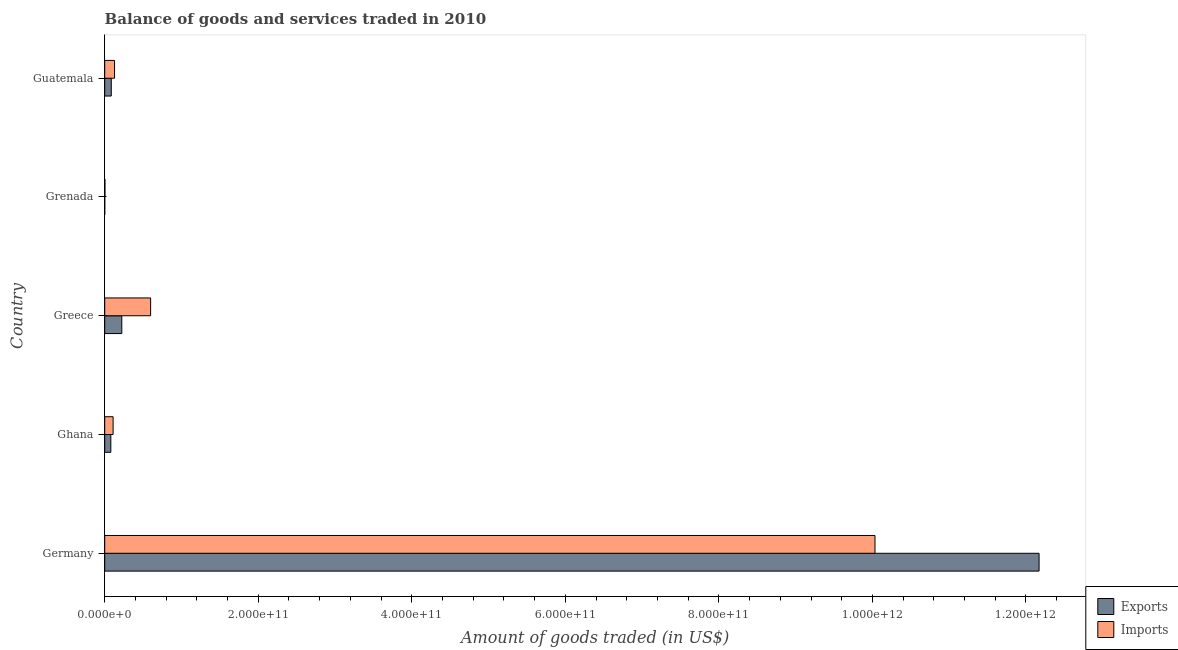How many groups of bars are there?
Your response must be concise. 5. What is the label of the 2nd group of bars from the top?
Give a very brief answer. Grenada. What is the amount of goods exported in Grenada?
Your answer should be very brief. 3.11e+07. Across all countries, what is the maximum amount of goods exported?
Offer a terse response. 1.22e+12. Across all countries, what is the minimum amount of goods imported?
Give a very brief answer. 2.86e+08. In which country was the amount of goods exported minimum?
Your answer should be very brief. Grenada. What is the total amount of goods imported in the graph?
Give a very brief answer. 1.09e+12. What is the difference between the amount of goods exported in Germany and that in Grenada?
Keep it short and to the point. 1.22e+12. What is the difference between the amount of goods exported in Grenada and the amount of goods imported in Ghana?
Provide a succinct answer. -1.09e+1. What is the average amount of goods imported per country?
Offer a terse response. 2.17e+11. What is the difference between the amount of goods imported and amount of goods exported in Guatemala?
Your response must be concise. 4.27e+09. What is the ratio of the amount of goods exported in Germany to that in Guatemala?
Your answer should be compact. 142.59. What is the difference between the highest and the second highest amount of goods imported?
Offer a terse response. 9.44e+11. What is the difference between the highest and the lowest amount of goods exported?
Keep it short and to the point. 1.22e+12. In how many countries, is the amount of goods imported greater than the average amount of goods imported taken over all countries?
Provide a short and direct response. 1. What does the 2nd bar from the top in Guatemala represents?
Provide a short and direct response. Exports. What does the 2nd bar from the bottom in Ghana represents?
Your answer should be compact. Imports. How many bars are there?
Offer a terse response. 10. Are all the bars in the graph horizontal?
Make the answer very short. Yes. How many countries are there in the graph?
Give a very brief answer. 5. What is the difference between two consecutive major ticks on the X-axis?
Offer a very short reply. 2.00e+11. Does the graph contain any zero values?
Your answer should be compact. No. Where does the legend appear in the graph?
Keep it short and to the point. Bottom right. How many legend labels are there?
Provide a succinct answer. 2. How are the legend labels stacked?
Make the answer very short. Vertical. What is the title of the graph?
Give a very brief answer. Balance of goods and services traded in 2010. What is the label or title of the X-axis?
Your response must be concise. Amount of goods traded (in US$). What is the Amount of goods traded (in US$) in Exports in Germany?
Give a very brief answer. 1.22e+12. What is the Amount of goods traded (in US$) in Imports in Germany?
Make the answer very short. 1.00e+12. What is the Amount of goods traded (in US$) of Exports in Ghana?
Provide a succinct answer. 7.96e+09. What is the Amount of goods traded (in US$) in Imports in Ghana?
Provide a short and direct response. 1.09e+1. What is the Amount of goods traded (in US$) of Exports in Greece?
Give a very brief answer. 2.22e+1. What is the Amount of goods traded (in US$) of Imports in Greece?
Offer a terse response. 5.98e+1. What is the Amount of goods traded (in US$) in Exports in Grenada?
Offer a terse response. 3.11e+07. What is the Amount of goods traded (in US$) in Imports in Grenada?
Make the answer very short. 2.86e+08. What is the Amount of goods traded (in US$) in Exports in Guatemala?
Offer a terse response. 8.54e+09. What is the Amount of goods traded (in US$) of Imports in Guatemala?
Your answer should be compact. 1.28e+1. Across all countries, what is the maximum Amount of goods traded (in US$) in Exports?
Your response must be concise. 1.22e+12. Across all countries, what is the maximum Amount of goods traded (in US$) of Imports?
Offer a terse response. 1.00e+12. Across all countries, what is the minimum Amount of goods traded (in US$) of Exports?
Ensure brevity in your answer.  3.11e+07. Across all countries, what is the minimum Amount of goods traded (in US$) of Imports?
Make the answer very short. 2.86e+08. What is the total Amount of goods traded (in US$) of Exports in the graph?
Give a very brief answer. 1.26e+12. What is the total Amount of goods traded (in US$) of Imports in the graph?
Offer a very short reply. 1.09e+12. What is the difference between the Amount of goods traded (in US$) of Exports in Germany and that in Ghana?
Offer a terse response. 1.21e+12. What is the difference between the Amount of goods traded (in US$) in Imports in Germany and that in Ghana?
Your answer should be compact. 9.92e+11. What is the difference between the Amount of goods traded (in US$) of Exports in Germany and that in Greece?
Ensure brevity in your answer.  1.19e+12. What is the difference between the Amount of goods traded (in US$) in Imports in Germany and that in Greece?
Provide a succinct answer. 9.44e+11. What is the difference between the Amount of goods traded (in US$) in Exports in Germany and that in Grenada?
Keep it short and to the point. 1.22e+12. What is the difference between the Amount of goods traded (in US$) in Imports in Germany and that in Grenada?
Your response must be concise. 1.00e+12. What is the difference between the Amount of goods traded (in US$) in Exports in Germany and that in Guatemala?
Offer a terse response. 1.21e+12. What is the difference between the Amount of goods traded (in US$) of Imports in Germany and that in Guatemala?
Keep it short and to the point. 9.91e+11. What is the difference between the Amount of goods traded (in US$) of Exports in Ghana and that in Greece?
Offer a very short reply. -1.43e+1. What is the difference between the Amount of goods traded (in US$) in Imports in Ghana and that in Greece?
Your answer should be very brief. -4.89e+1. What is the difference between the Amount of goods traded (in US$) in Exports in Ghana and that in Grenada?
Provide a succinct answer. 7.93e+09. What is the difference between the Amount of goods traded (in US$) in Imports in Ghana and that in Grenada?
Provide a succinct answer. 1.06e+1. What is the difference between the Amount of goods traded (in US$) in Exports in Ghana and that in Guatemala?
Your answer should be compact. -5.75e+08. What is the difference between the Amount of goods traded (in US$) in Imports in Ghana and that in Guatemala?
Your answer should be very brief. -1.88e+09. What is the difference between the Amount of goods traded (in US$) of Exports in Greece and that in Grenada?
Provide a succinct answer. 2.22e+1. What is the difference between the Amount of goods traded (in US$) of Imports in Greece and that in Grenada?
Your response must be concise. 5.95e+1. What is the difference between the Amount of goods traded (in US$) in Exports in Greece and that in Guatemala?
Give a very brief answer. 1.37e+1. What is the difference between the Amount of goods traded (in US$) in Imports in Greece and that in Guatemala?
Your answer should be compact. 4.70e+1. What is the difference between the Amount of goods traded (in US$) of Exports in Grenada and that in Guatemala?
Give a very brief answer. -8.50e+09. What is the difference between the Amount of goods traded (in US$) of Imports in Grenada and that in Guatemala?
Provide a short and direct response. -1.25e+1. What is the difference between the Amount of goods traded (in US$) in Exports in Germany and the Amount of goods traded (in US$) in Imports in Ghana?
Keep it short and to the point. 1.21e+12. What is the difference between the Amount of goods traded (in US$) in Exports in Germany and the Amount of goods traded (in US$) in Imports in Greece?
Your answer should be compact. 1.16e+12. What is the difference between the Amount of goods traded (in US$) of Exports in Germany and the Amount of goods traded (in US$) of Imports in Grenada?
Your answer should be very brief. 1.22e+12. What is the difference between the Amount of goods traded (in US$) of Exports in Germany and the Amount of goods traded (in US$) of Imports in Guatemala?
Give a very brief answer. 1.20e+12. What is the difference between the Amount of goods traded (in US$) of Exports in Ghana and the Amount of goods traded (in US$) of Imports in Greece?
Your response must be concise. -5.18e+1. What is the difference between the Amount of goods traded (in US$) of Exports in Ghana and the Amount of goods traded (in US$) of Imports in Grenada?
Offer a very short reply. 7.67e+09. What is the difference between the Amount of goods traded (in US$) of Exports in Ghana and the Amount of goods traded (in US$) of Imports in Guatemala?
Offer a terse response. -4.85e+09. What is the difference between the Amount of goods traded (in US$) of Exports in Greece and the Amount of goods traded (in US$) of Imports in Grenada?
Your answer should be very brief. 2.20e+1. What is the difference between the Amount of goods traded (in US$) in Exports in Greece and the Amount of goods traded (in US$) in Imports in Guatemala?
Make the answer very short. 9.44e+09. What is the difference between the Amount of goods traded (in US$) in Exports in Grenada and the Amount of goods traded (in US$) in Imports in Guatemala?
Provide a succinct answer. -1.28e+1. What is the average Amount of goods traded (in US$) in Exports per country?
Provide a succinct answer. 2.51e+11. What is the average Amount of goods traded (in US$) in Imports per country?
Offer a very short reply. 2.17e+11. What is the difference between the Amount of goods traded (in US$) of Exports and Amount of goods traded (in US$) of Imports in Germany?
Offer a terse response. 2.14e+11. What is the difference between the Amount of goods traded (in US$) of Exports and Amount of goods traded (in US$) of Imports in Ghana?
Your response must be concise. -2.96e+09. What is the difference between the Amount of goods traded (in US$) of Exports and Amount of goods traded (in US$) of Imports in Greece?
Offer a very short reply. -3.76e+1. What is the difference between the Amount of goods traded (in US$) of Exports and Amount of goods traded (in US$) of Imports in Grenada?
Give a very brief answer. -2.54e+08. What is the difference between the Amount of goods traded (in US$) in Exports and Amount of goods traded (in US$) in Imports in Guatemala?
Your answer should be very brief. -4.27e+09. What is the ratio of the Amount of goods traded (in US$) in Exports in Germany to that in Ghana?
Give a very brief answer. 152.9. What is the ratio of the Amount of goods traded (in US$) of Imports in Germany to that in Ghana?
Make the answer very short. 91.86. What is the ratio of the Amount of goods traded (in US$) in Exports in Germany to that in Greece?
Offer a terse response. 54.7. What is the ratio of the Amount of goods traded (in US$) of Imports in Germany to that in Greece?
Provide a short and direct response. 16.78. What is the ratio of the Amount of goods traded (in US$) of Exports in Germany to that in Grenada?
Offer a terse response. 3.91e+04. What is the ratio of the Amount of goods traded (in US$) in Imports in Germany to that in Grenada?
Offer a terse response. 3513.43. What is the ratio of the Amount of goods traded (in US$) in Exports in Germany to that in Guatemala?
Your answer should be compact. 142.59. What is the ratio of the Amount of goods traded (in US$) in Imports in Germany to that in Guatemala?
Your answer should be compact. 78.35. What is the ratio of the Amount of goods traded (in US$) of Exports in Ghana to that in Greece?
Provide a succinct answer. 0.36. What is the ratio of the Amount of goods traded (in US$) in Imports in Ghana to that in Greece?
Your answer should be compact. 0.18. What is the ratio of the Amount of goods traded (in US$) of Exports in Ghana to that in Grenada?
Give a very brief answer. 255.73. What is the ratio of the Amount of goods traded (in US$) in Imports in Ghana to that in Grenada?
Offer a very short reply. 38.25. What is the ratio of the Amount of goods traded (in US$) in Exports in Ghana to that in Guatemala?
Offer a terse response. 0.93. What is the ratio of the Amount of goods traded (in US$) of Imports in Ghana to that in Guatemala?
Provide a succinct answer. 0.85. What is the ratio of the Amount of goods traded (in US$) of Exports in Greece to that in Grenada?
Your answer should be compact. 714.8. What is the ratio of the Amount of goods traded (in US$) of Imports in Greece to that in Grenada?
Your answer should be very brief. 209.41. What is the ratio of the Amount of goods traded (in US$) of Exports in Greece to that in Guatemala?
Your response must be concise. 2.61. What is the ratio of the Amount of goods traded (in US$) of Imports in Greece to that in Guatemala?
Offer a very short reply. 4.67. What is the ratio of the Amount of goods traded (in US$) in Exports in Grenada to that in Guatemala?
Your answer should be compact. 0. What is the ratio of the Amount of goods traded (in US$) in Imports in Grenada to that in Guatemala?
Keep it short and to the point. 0.02. What is the difference between the highest and the second highest Amount of goods traded (in US$) in Exports?
Ensure brevity in your answer.  1.19e+12. What is the difference between the highest and the second highest Amount of goods traded (in US$) in Imports?
Your answer should be very brief. 9.44e+11. What is the difference between the highest and the lowest Amount of goods traded (in US$) of Exports?
Keep it short and to the point. 1.22e+12. What is the difference between the highest and the lowest Amount of goods traded (in US$) in Imports?
Your answer should be compact. 1.00e+12. 